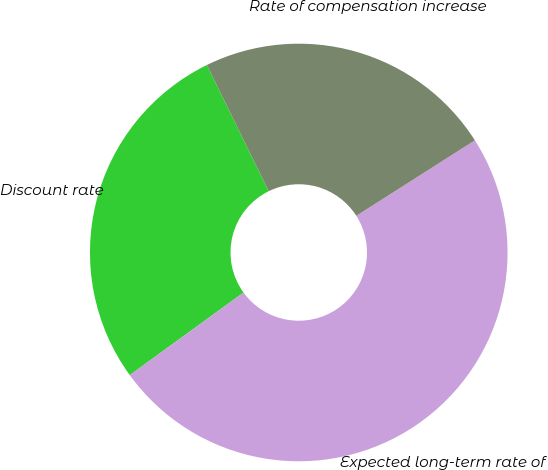<chart> <loc_0><loc_0><loc_500><loc_500><pie_chart><fcel>Discount rate<fcel>Expected long-term rate of<fcel>Rate of compensation increase<nl><fcel>27.74%<fcel>49.03%<fcel>23.23%<nl></chart> 